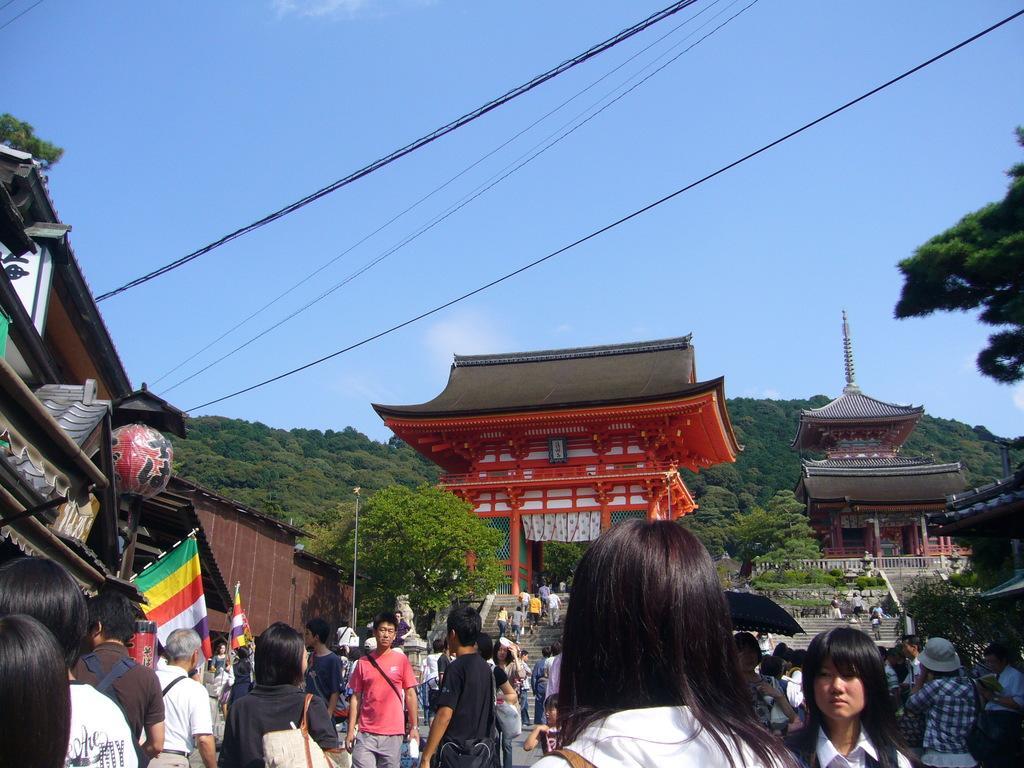Describe this image in one or two sentences. There are people in the foreground area of the image, there are buildings, flags, model of a ball, it seems like mountains and the sky in the background. 